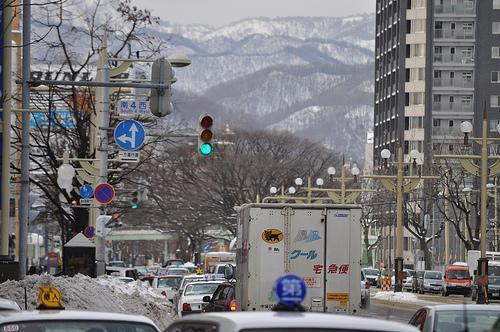How many red cars are in this picture?
Give a very brief answer. 1. How many people are touching traffic light?
Give a very brief answer. 0. 